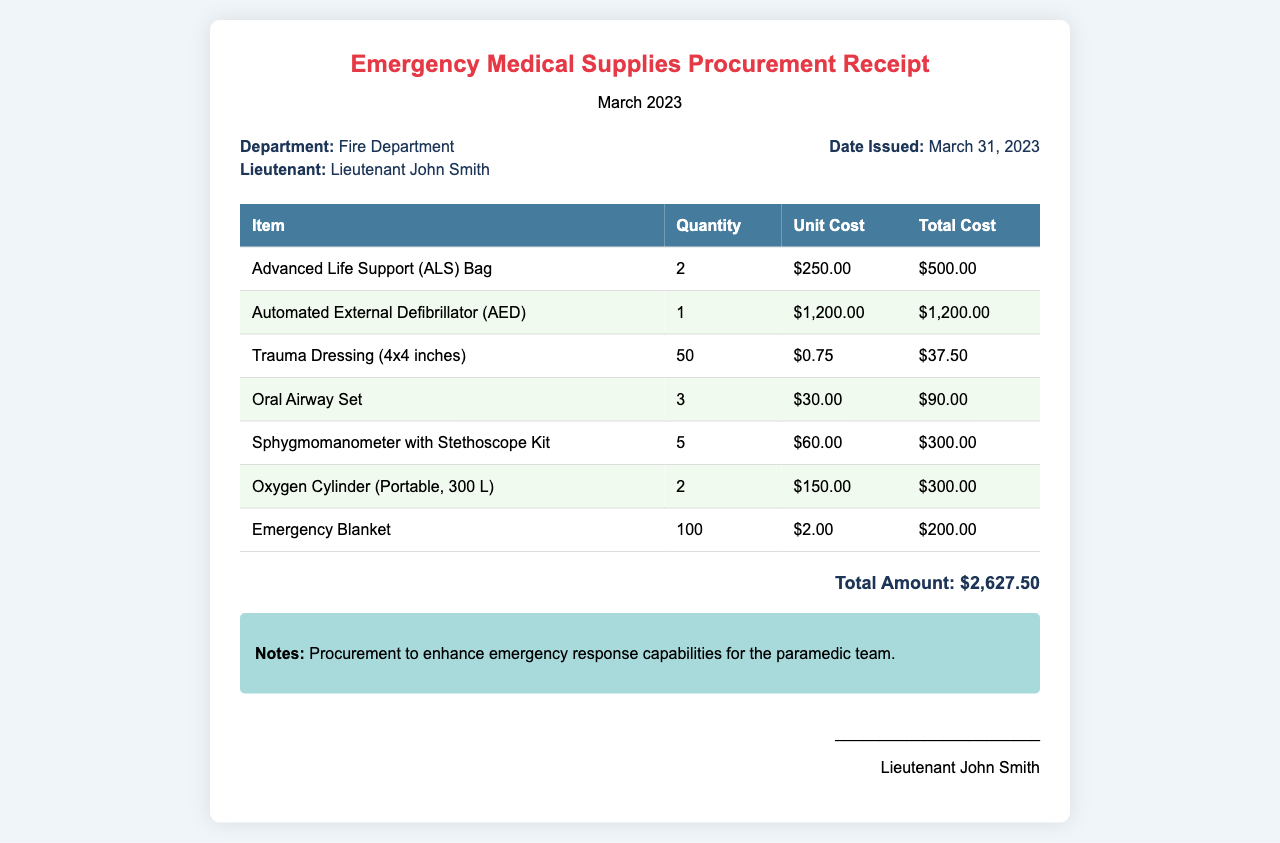What is the total amount for the procurement? The total amount is stated at the bottom of the receipt after summing up all the costs of the items purchased.
Answer: $2,627.50 How many Emergency Blankets were purchased? The quantity of Emergency Blankets is indicated in the table under the Quantity column for that specific item.
Answer: 100 What is the unit cost of the Automated External Defibrillator? The unit cost can be found in the table under the Unit Cost column for that specific item.
Answer: $1,200.00 Who issued the receipt? The name of the person issuing the receipt is mentioned in the signature section at the bottom of the document.
Answer: Lieutenant John Smith What item has the highest unit cost? To find this, we compare the unit costs listed in the table and identify the highest one.
Answer: Automated External Defibrillator How many Trauma Dressings were ordered? The number of Trauma Dressings can be found in the table under the Quantity column for that item.
Answer: 50 What is the date the receipt was issued? The date issued is mentioned in the info section of the receipt.
Answer: March 31, 2023 What procurement purpose is noted in the document? The purpose for procurement can be found in the Notes section at the bottom of the receipt.
Answer: Enhance emergency response capabilities for the paramedic team 